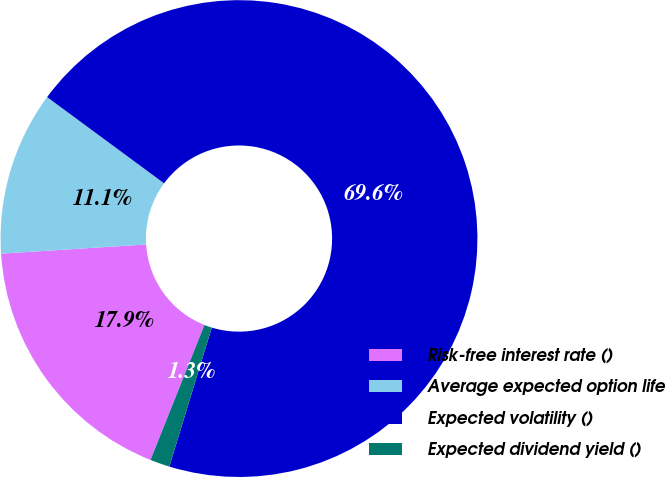Convert chart. <chart><loc_0><loc_0><loc_500><loc_500><pie_chart><fcel>Risk-free interest rate ()<fcel>Average expected option life<fcel>Expected volatility ()<fcel>Expected dividend yield ()<nl><fcel>17.94%<fcel>11.12%<fcel>69.61%<fcel>1.33%<nl></chart> 